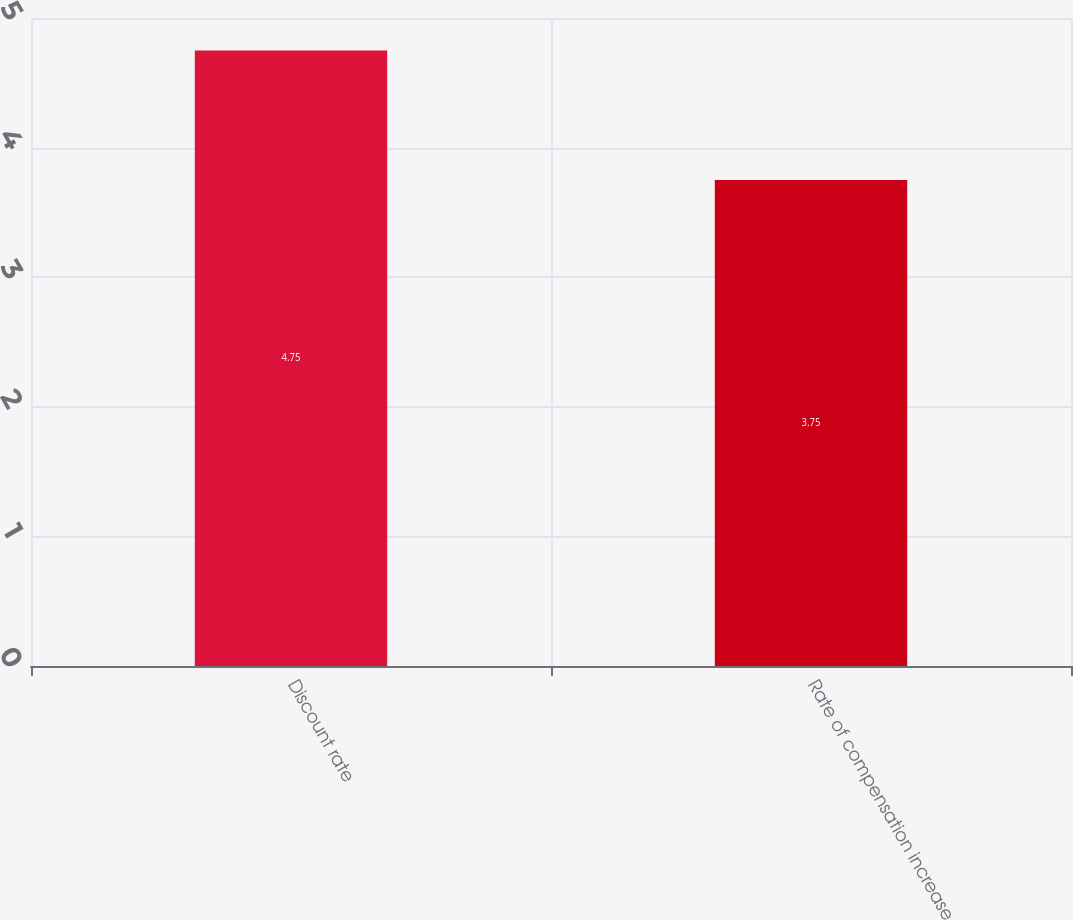Convert chart. <chart><loc_0><loc_0><loc_500><loc_500><bar_chart><fcel>Discount rate<fcel>Rate of compensation increase<nl><fcel>4.75<fcel>3.75<nl></chart> 